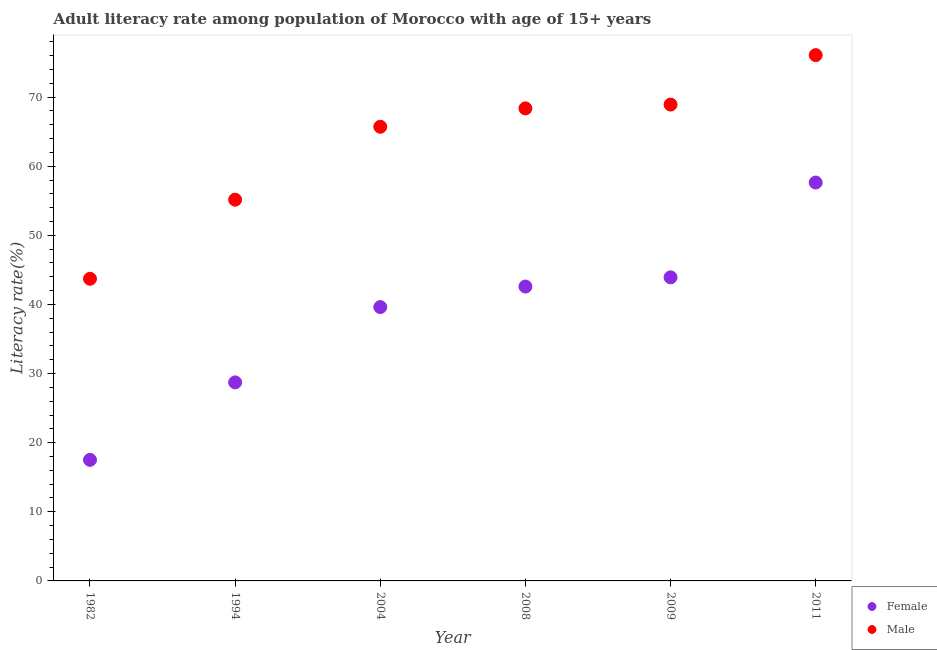Is the number of dotlines equal to the number of legend labels?
Offer a terse response. Yes. What is the female adult literacy rate in 1994?
Make the answer very short. 28.73. Across all years, what is the maximum female adult literacy rate?
Offer a very short reply. 57.64. Across all years, what is the minimum female adult literacy rate?
Offer a terse response. 17.51. In which year was the female adult literacy rate minimum?
Your answer should be very brief. 1982. What is the total male adult literacy rate in the graph?
Offer a very short reply. 377.93. What is the difference between the female adult literacy rate in 1994 and that in 2008?
Your answer should be very brief. -13.86. What is the difference between the female adult literacy rate in 2004 and the male adult literacy rate in 2008?
Make the answer very short. -28.75. What is the average male adult literacy rate per year?
Keep it short and to the point. 62.99. In the year 1994, what is the difference between the female adult literacy rate and male adult literacy rate?
Your answer should be very brief. -26.43. What is the ratio of the male adult literacy rate in 2009 to that in 2011?
Provide a succinct answer. 0.91. Is the male adult literacy rate in 2008 less than that in 2011?
Give a very brief answer. Yes. Is the difference between the female adult literacy rate in 1982 and 2009 greater than the difference between the male adult literacy rate in 1982 and 2009?
Your response must be concise. No. What is the difference between the highest and the second highest female adult literacy rate?
Ensure brevity in your answer.  13.72. What is the difference between the highest and the lowest male adult literacy rate?
Keep it short and to the point. 32.36. In how many years, is the female adult literacy rate greater than the average female adult literacy rate taken over all years?
Your response must be concise. 4. Is the female adult literacy rate strictly greater than the male adult literacy rate over the years?
Offer a terse response. No. Is the female adult literacy rate strictly less than the male adult literacy rate over the years?
Make the answer very short. Yes. How many years are there in the graph?
Offer a very short reply. 6. Are the values on the major ticks of Y-axis written in scientific E-notation?
Your answer should be compact. No. Does the graph contain any zero values?
Your answer should be very brief. No. Does the graph contain grids?
Give a very brief answer. No. Where does the legend appear in the graph?
Your answer should be very brief. Bottom right. How many legend labels are there?
Offer a terse response. 2. How are the legend labels stacked?
Keep it short and to the point. Vertical. What is the title of the graph?
Provide a succinct answer. Adult literacy rate among population of Morocco with age of 15+ years. What is the label or title of the Y-axis?
Your answer should be compact. Literacy rate(%). What is the Literacy rate(%) in Female in 1982?
Provide a short and direct response. 17.51. What is the Literacy rate(%) in Male in 1982?
Make the answer very short. 43.71. What is the Literacy rate(%) in Female in 1994?
Keep it short and to the point. 28.73. What is the Literacy rate(%) of Male in 1994?
Provide a short and direct response. 55.16. What is the Literacy rate(%) of Female in 2004?
Give a very brief answer. 39.62. What is the Literacy rate(%) of Male in 2004?
Your response must be concise. 65.71. What is the Literacy rate(%) in Female in 2008?
Offer a very short reply. 42.59. What is the Literacy rate(%) in Male in 2008?
Ensure brevity in your answer.  68.37. What is the Literacy rate(%) in Female in 2009?
Your response must be concise. 43.92. What is the Literacy rate(%) of Male in 2009?
Offer a terse response. 68.92. What is the Literacy rate(%) of Female in 2011?
Provide a short and direct response. 57.64. What is the Literacy rate(%) of Male in 2011?
Make the answer very short. 76.07. Across all years, what is the maximum Literacy rate(%) in Female?
Give a very brief answer. 57.64. Across all years, what is the maximum Literacy rate(%) in Male?
Your response must be concise. 76.07. Across all years, what is the minimum Literacy rate(%) in Female?
Your response must be concise. 17.51. Across all years, what is the minimum Literacy rate(%) in Male?
Provide a succinct answer. 43.71. What is the total Literacy rate(%) in Female in the graph?
Provide a succinct answer. 230.01. What is the total Literacy rate(%) of Male in the graph?
Provide a succinct answer. 377.93. What is the difference between the Literacy rate(%) of Female in 1982 and that in 1994?
Ensure brevity in your answer.  -11.21. What is the difference between the Literacy rate(%) in Male in 1982 and that in 1994?
Make the answer very short. -11.44. What is the difference between the Literacy rate(%) in Female in 1982 and that in 2004?
Give a very brief answer. -22.1. What is the difference between the Literacy rate(%) of Male in 1982 and that in 2004?
Keep it short and to the point. -21.99. What is the difference between the Literacy rate(%) in Female in 1982 and that in 2008?
Your response must be concise. -25.07. What is the difference between the Literacy rate(%) of Male in 1982 and that in 2008?
Make the answer very short. -24.65. What is the difference between the Literacy rate(%) of Female in 1982 and that in 2009?
Keep it short and to the point. -26.41. What is the difference between the Literacy rate(%) in Male in 1982 and that in 2009?
Provide a succinct answer. -25.2. What is the difference between the Literacy rate(%) of Female in 1982 and that in 2011?
Offer a terse response. -40.13. What is the difference between the Literacy rate(%) of Male in 1982 and that in 2011?
Offer a very short reply. -32.36. What is the difference between the Literacy rate(%) of Female in 1994 and that in 2004?
Offer a very short reply. -10.89. What is the difference between the Literacy rate(%) in Male in 1994 and that in 2004?
Provide a short and direct response. -10.55. What is the difference between the Literacy rate(%) of Female in 1994 and that in 2008?
Make the answer very short. -13.86. What is the difference between the Literacy rate(%) in Male in 1994 and that in 2008?
Ensure brevity in your answer.  -13.21. What is the difference between the Literacy rate(%) of Female in 1994 and that in 2009?
Provide a short and direct response. -15.2. What is the difference between the Literacy rate(%) in Male in 1994 and that in 2009?
Provide a short and direct response. -13.76. What is the difference between the Literacy rate(%) of Female in 1994 and that in 2011?
Provide a short and direct response. -28.91. What is the difference between the Literacy rate(%) in Male in 1994 and that in 2011?
Offer a very short reply. -20.92. What is the difference between the Literacy rate(%) in Female in 2004 and that in 2008?
Keep it short and to the point. -2.97. What is the difference between the Literacy rate(%) of Male in 2004 and that in 2008?
Keep it short and to the point. -2.66. What is the difference between the Literacy rate(%) of Female in 2004 and that in 2009?
Provide a succinct answer. -4.3. What is the difference between the Literacy rate(%) in Male in 2004 and that in 2009?
Offer a very short reply. -3.21. What is the difference between the Literacy rate(%) in Female in 2004 and that in 2011?
Provide a short and direct response. -18.02. What is the difference between the Literacy rate(%) in Male in 2004 and that in 2011?
Provide a succinct answer. -10.37. What is the difference between the Literacy rate(%) of Female in 2008 and that in 2009?
Provide a short and direct response. -1.33. What is the difference between the Literacy rate(%) in Male in 2008 and that in 2009?
Keep it short and to the point. -0.55. What is the difference between the Literacy rate(%) of Female in 2008 and that in 2011?
Your response must be concise. -15.05. What is the difference between the Literacy rate(%) in Male in 2008 and that in 2011?
Your answer should be compact. -7.71. What is the difference between the Literacy rate(%) in Female in 2009 and that in 2011?
Make the answer very short. -13.72. What is the difference between the Literacy rate(%) of Male in 2009 and that in 2011?
Make the answer very short. -7.16. What is the difference between the Literacy rate(%) in Female in 1982 and the Literacy rate(%) in Male in 1994?
Your answer should be very brief. -37.64. What is the difference between the Literacy rate(%) of Female in 1982 and the Literacy rate(%) of Male in 2004?
Your answer should be compact. -48.19. What is the difference between the Literacy rate(%) in Female in 1982 and the Literacy rate(%) in Male in 2008?
Ensure brevity in your answer.  -50.85. What is the difference between the Literacy rate(%) of Female in 1982 and the Literacy rate(%) of Male in 2009?
Keep it short and to the point. -51.4. What is the difference between the Literacy rate(%) in Female in 1982 and the Literacy rate(%) in Male in 2011?
Your answer should be very brief. -58.56. What is the difference between the Literacy rate(%) in Female in 1994 and the Literacy rate(%) in Male in 2004?
Provide a succinct answer. -36.98. What is the difference between the Literacy rate(%) in Female in 1994 and the Literacy rate(%) in Male in 2008?
Provide a succinct answer. -39.64. What is the difference between the Literacy rate(%) of Female in 1994 and the Literacy rate(%) of Male in 2009?
Give a very brief answer. -40.19. What is the difference between the Literacy rate(%) of Female in 1994 and the Literacy rate(%) of Male in 2011?
Your answer should be very brief. -47.35. What is the difference between the Literacy rate(%) in Female in 2004 and the Literacy rate(%) in Male in 2008?
Your answer should be compact. -28.75. What is the difference between the Literacy rate(%) of Female in 2004 and the Literacy rate(%) of Male in 2009?
Offer a very short reply. -29.3. What is the difference between the Literacy rate(%) of Female in 2004 and the Literacy rate(%) of Male in 2011?
Your response must be concise. -36.45. What is the difference between the Literacy rate(%) in Female in 2008 and the Literacy rate(%) in Male in 2009?
Your answer should be compact. -26.33. What is the difference between the Literacy rate(%) in Female in 2008 and the Literacy rate(%) in Male in 2011?
Provide a succinct answer. -33.49. What is the difference between the Literacy rate(%) of Female in 2009 and the Literacy rate(%) of Male in 2011?
Make the answer very short. -32.15. What is the average Literacy rate(%) in Female per year?
Offer a terse response. 38.33. What is the average Literacy rate(%) in Male per year?
Provide a short and direct response. 62.99. In the year 1982, what is the difference between the Literacy rate(%) of Female and Literacy rate(%) of Male?
Make the answer very short. -26.2. In the year 1994, what is the difference between the Literacy rate(%) in Female and Literacy rate(%) in Male?
Provide a short and direct response. -26.43. In the year 2004, what is the difference between the Literacy rate(%) of Female and Literacy rate(%) of Male?
Your answer should be very brief. -26.09. In the year 2008, what is the difference between the Literacy rate(%) in Female and Literacy rate(%) in Male?
Ensure brevity in your answer.  -25.78. In the year 2009, what is the difference between the Literacy rate(%) of Female and Literacy rate(%) of Male?
Ensure brevity in your answer.  -25. In the year 2011, what is the difference between the Literacy rate(%) in Female and Literacy rate(%) in Male?
Your answer should be very brief. -18.43. What is the ratio of the Literacy rate(%) of Female in 1982 to that in 1994?
Provide a succinct answer. 0.61. What is the ratio of the Literacy rate(%) in Male in 1982 to that in 1994?
Your answer should be very brief. 0.79. What is the ratio of the Literacy rate(%) of Female in 1982 to that in 2004?
Offer a terse response. 0.44. What is the ratio of the Literacy rate(%) of Male in 1982 to that in 2004?
Keep it short and to the point. 0.67. What is the ratio of the Literacy rate(%) in Female in 1982 to that in 2008?
Make the answer very short. 0.41. What is the ratio of the Literacy rate(%) of Male in 1982 to that in 2008?
Give a very brief answer. 0.64. What is the ratio of the Literacy rate(%) in Female in 1982 to that in 2009?
Offer a very short reply. 0.4. What is the ratio of the Literacy rate(%) of Male in 1982 to that in 2009?
Offer a terse response. 0.63. What is the ratio of the Literacy rate(%) in Female in 1982 to that in 2011?
Make the answer very short. 0.3. What is the ratio of the Literacy rate(%) of Male in 1982 to that in 2011?
Ensure brevity in your answer.  0.57. What is the ratio of the Literacy rate(%) in Female in 1994 to that in 2004?
Ensure brevity in your answer.  0.72. What is the ratio of the Literacy rate(%) of Male in 1994 to that in 2004?
Give a very brief answer. 0.84. What is the ratio of the Literacy rate(%) of Female in 1994 to that in 2008?
Give a very brief answer. 0.67. What is the ratio of the Literacy rate(%) of Male in 1994 to that in 2008?
Offer a very short reply. 0.81. What is the ratio of the Literacy rate(%) of Female in 1994 to that in 2009?
Your response must be concise. 0.65. What is the ratio of the Literacy rate(%) in Male in 1994 to that in 2009?
Your answer should be very brief. 0.8. What is the ratio of the Literacy rate(%) in Female in 1994 to that in 2011?
Your response must be concise. 0.5. What is the ratio of the Literacy rate(%) in Male in 1994 to that in 2011?
Provide a short and direct response. 0.72. What is the ratio of the Literacy rate(%) of Female in 2004 to that in 2008?
Keep it short and to the point. 0.93. What is the ratio of the Literacy rate(%) of Male in 2004 to that in 2008?
Give a very brief answer. 0.96. What is the ratio of the Literacy rate(%) in Female in 2004 to that in 2009?
Give a very brief answer. 0.9. What is the ratio of the Literacy rate(%) in Male in 2004 to that in 2009?
Ensure brevity in your answer.  0.95. What is the ratio of the Literacy rate(%) in Female in 2004 to that in 2011?
Ensure brevity in your answer.  0.69. What is the ratio of the Literacy rate(%) in Male in 2004 to that in 2011?
Your response must be concise. 0.86. What is the ratio of the Literacy rate(%) of Female in 2008 to that in 2009?
Your answer should be compact. 0.97. What is the ratio of the Literacy rate(%) of Female in 2008 to that in 2011?
Keep it short and to the point. 0.74. What is the ratio of the Literacy rate(%) of Male in 2008 to that in 2011?
Make the answer very short. 0.9. What is the ratio of the Literacy rate(%) in Female in 2009 to that in 2011?
Your answer should be very brief. 0.76. What is the ratio of the Literacy rate(%) of Male in 2009 to that in 2011?
Make the answer very short. 0.91. What is the difference between the highest and the second highest Literacy rate(%) in Female?
Your response must be concise. 13.72. What is the difference between the highest and the second highest Literacy rate(%) of Male?
Make the answer very short. 7.16. What is the difference between the highest and the lowest Literacy rate(%) in Female?
Make the answer very short. 40.13. What is the difference between the highest and the lowest Literacy rate(%) in Male?
Give a very brief answer. 32.36. 